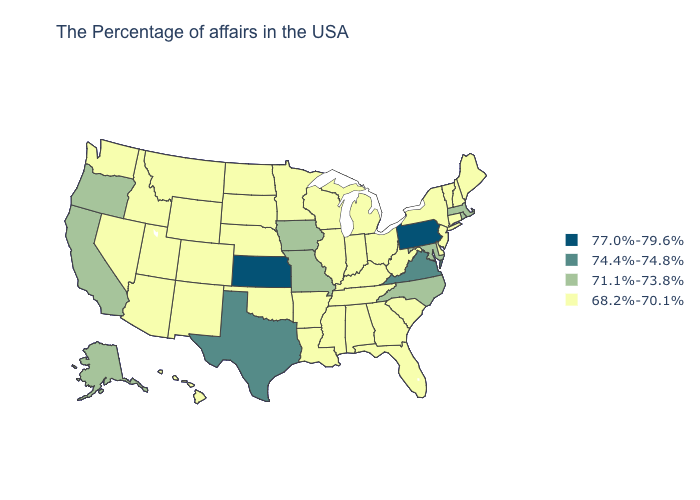What is the value of Alaska?
Answer briefly. 71.1%-73.8%. What is the value of Virginia?
Write a very short answer. 74.4%-74.8%. What is the highest value in the South ?
Write a very short answer. 74.4%-74.8%. Does Nebraska have the highest value in the MidWest?
Concise answer only. No. Among the states that border Wisconsin , does Michigan have the highest value?
Concise answer only. No. Name the states that have a value in the range 71.1%-73.8%?
Quick response, please. Massachusetts, Rhode Island, Maryland, North Carolina, Missouri, Iowa, California, Oregon, Alaska. Name the states that have a value in the range 68.2%-70.1%?
Give a very brief answer. Maine, New Hampshire, Vermont, Connecticut, New York, New Jersey, Delaware, South Carolina, West Virginia, Ohio, Florida, Georgia, Michigan, Kentucky, Indiana, Alabama, Tennessee, Wisconsin, Illinois, Mississippi, Louisiana, Arkansas, Minnesota, Nebraska, Oklahoma, South Dakota, North Dakota, Wyoming, Colorado, New Mexico, Utah, Montana, Arizona, Idaho, Nevada, Washington, Hawaii. Is the legend a continuous bar?
Give a very brief answer. No. What is the highest value in the Northeast ?
Concise answer only. 77.0%-79.6%. Does Massachusetts have the lowest value in the USA?
Quick response, please. No. Name the states that have a value in the range 74.4%-74.8%?
Quick response, please. Virginia, Texas. Does Minnesota have the lowest value in the USA?
Keep it brief. Yes. What is the value of Texas?
Short answer required. 74.4%-74.8%. What is the value of Pennsylvania?
Keep it brief. 77.0%-79.6%. 